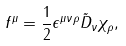Convert formula to latex. <formula><loc_0><loc_0><loc_500><loc_500>f ^ { \mu } = \frac { 1 } { 2 } \epsilon ^ { \mu \nu \rho } \tilde { D } _ { \nu } { \chi } _ { \rho } ,</formula> 